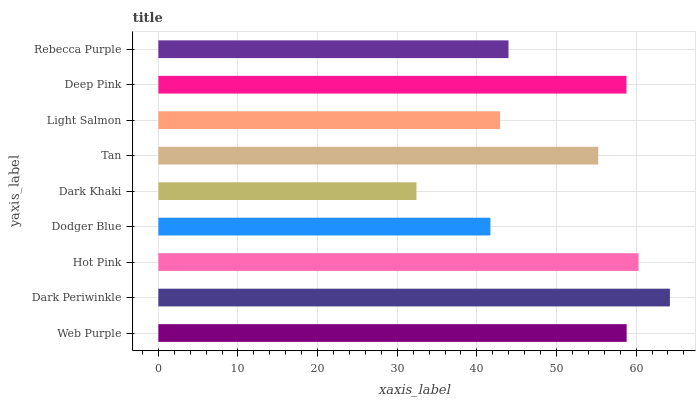Is Dark Khaki the minimum?
Answer yes or no. Yes. Is Dark Periwinkle the maximum?
Answer yes or no. Yes. Is Hot Pink the minimum?
Answer yes or no. No. Is Hot Pink the maximum?
Answer yes or no. No. Is Dark Periwinkle greater than Hot Pink?
Answer yes or no. Yes. Is Hot Pink less than Dark Periwinkle?
Answer yes or no. Yes. Is Hot Pink greater than Dark Periwinkle?
Answer yes or no. No. Is Dark Periwinkle less than Hot Pink?
Answer yes or no. No. Is Tan the high median?
Answer yes or no. Yes. Is Tan the low median?
Answer yes or no. Yes. Is Rebecca Purple the high median?
Answer yes or no. No. Is Hot Pink the low median?
Answer yes or no. No. 